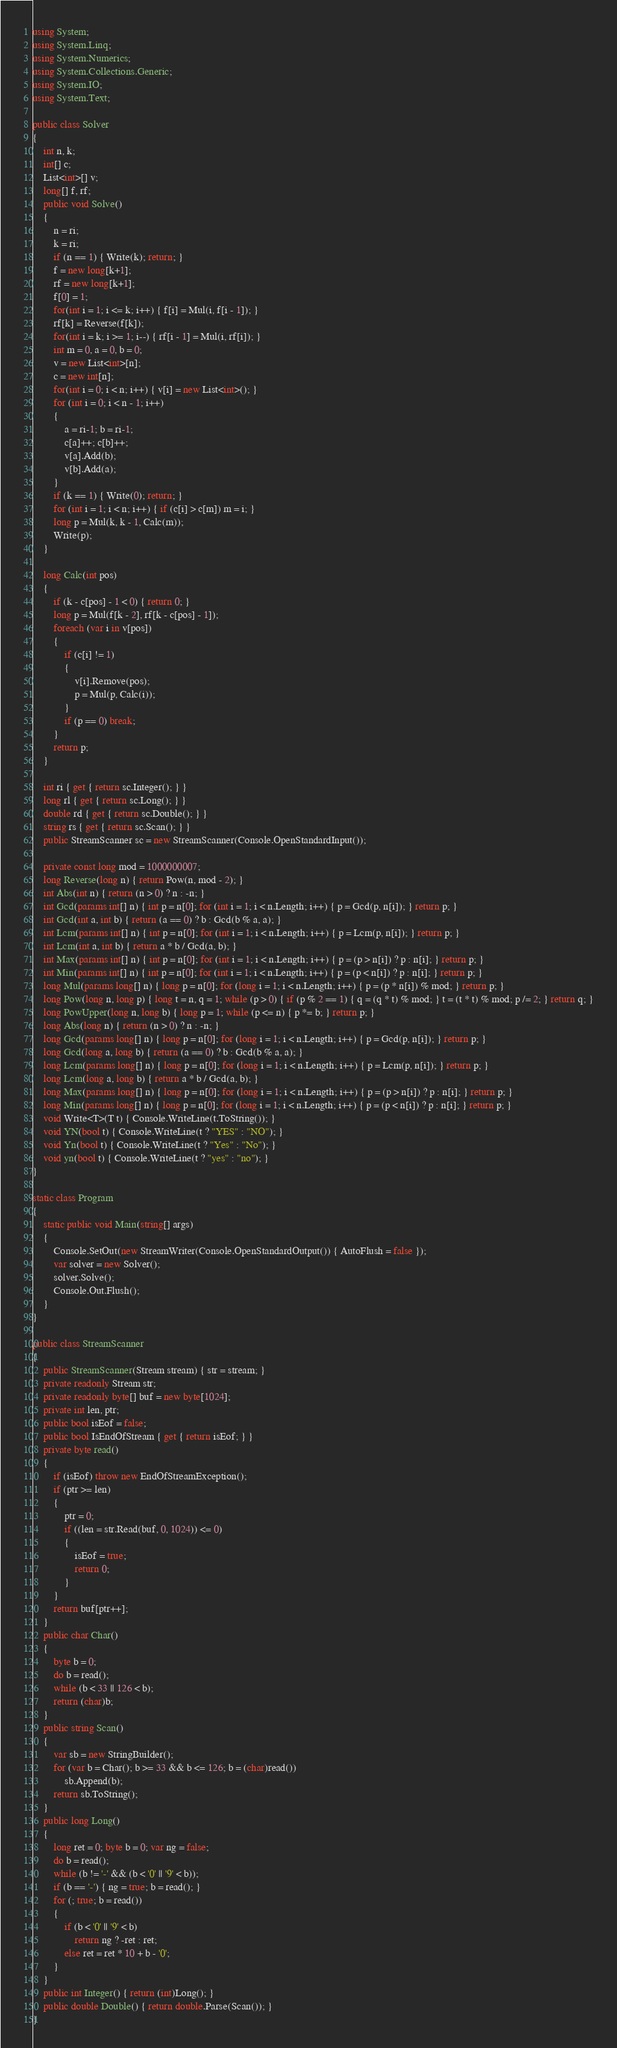Convert code to text. <code><loc_0><loc_0><loc_500><loc_500><_C#_>using System;
using System.Linq;
using System.Numerics;
using System.Collections.Generic;
using System.IO;
using System.Text;

public class Solver
{
    int n, k;
    int[] c;
    List<int>[] v;
    long[] f, rf;
    public void Solve()
    {
        n = ri;
        k = ri;
        if (n == 1) { Write(k); return; }
        f = new long[k+1];
        rf = new long[k+1];
        f[0] = 1;
        for(int i = 1; i <= k; i++) { f[i] = Mul(i, f[i - 1]); }
        rf[k] = Reverse(f[k]);
        for(int i = k; i >= 1; i--) { rf[i - 1] = Mul(i, rf[i]); }
        int m = 0, a = 0, b = 0;
        v = new List<int>[n];
        c = new int[n];
        for(int i = 0; i < n; i++) { v[i] = new List<int>(); }
        for (int i = 0; i < n - 1; i++)
        {
            a = ri-1; b = ri-1;
            c[a]++; c[b]++;
            v[a].Add(b);
            v[b].Add(a);
        }
        if (k == 1) { Write(0); return; }
        for (int i = 1; i < n; i++) { if (c[i] > c[m]) m = i; }
        long p = Mul(k, k - 1, Calc(m));
        Write(p);
    }

    long Calc(int pos)
    {
        if (k - c[pos] - 1 < 0) { return 0; }
        long p = Mul(f[k - 2], rf[k - c[pos] - 1]);
        foreach (var i in v[pos])
        {
            if (c[i] != 1)
            {
                v[i].Remove(pos);
                p = Mul(p, Calc(i));
            }
            if (p == 0) break;
        }
        return p;
    }

    int ri { get { return sc.Integer(); } }
    long rl { get { return sc.Long(); } }
    double rd { get { return sc.Double(); } }
    string rs { get { return sc.Scan(); } }
    public StreamScanner sc = new StreamScanner(Console.OpenStandardInput());
    
    private const long mod = 1000000007;
    long Reverse(long n) { return Pow(n, mod - 2); }
    int Abs(int n) { return (n > 0) ? n : -n; }
    int Gcd(params int[] n) { int p = n[0]; for (int i = 1; i < n.Length; i++) { p = Gcd(p, n[i]); } return p; }
    int Gcd(int a, int b) { return (a == 0) ? b : Gcd(b % a, a); }
    int Lcm(params int[] n) { int p = n[0]; for (int i = 1; i < n.Length; i++) { p = Lcm(p, n[i]); } return p; }
    int Lcm(int a, int b) { return a * b / Gcd(a, b); }
    int Max(params int[] n) { int p = n[0]; for (int i = 1; i < n.Length; i++) { p = (p > n[i]) ? p : n[i]; } return p; }
    int Min(params int[] n) { int p = n[0]; for (int i = 1; i < n.Length; i++) { p = (p < n[i]) ? p : n[i]; } return p; }
    long Mul(params long[] n) { long p = n[0]; for (long i = 1; i < n.Length; i++) { p = (p * n[i]) % mod; } return p; }
    long Pow(long n, long p) { long t = n, q = 1; while (p > 0) { if (p % 2 == 1) { q = (q * t) % mod; } t = (t * t) % mod; p /= 2; } return q; }
    long PowUpper(long n, long b) { long p = 1; while (p <= n) { p *= b; } return p; }
    long Abs(long n) { return (n > 0) ? n : -n; }
    long Gcd(params long[] n) { long p = n[0]; for (long i = 1; i < n.Length; i++) { p = Gcd(p, n[i]); } return p; }
    long Gcd(long a, long b) { return (a == 0) ? b : Gcd(b % a, a); }
    long Lcm(params long[] n) { long p = n[0]; for (long i = 1; i < n.Length; i++) { p = Lcm(p, n[i]); } return p; }
    long Lcm(long a, long b) { return a * b / Gcd(a, b); }
    long Max(params long[] n) { long p = n[0]; for (long i = 1; i < n.Length; i++) { p = (p > n[i]) ? p : n[i]; } return p; }
    long Min(params long[] n) { long p = n[0]; for (long i = 1; i < n.Length; i++) { p = (p < n[i]) ? p : n[i]; } return p; }
    void Write<T>(T t) { Console.WriteLine(t.ToString()); }
    void YN(bool t) { Console.WriteLine(t ? "YES" : "NO"); }
    void Yn(bool t) { Console.WriteLine(t ? "Yes" : "No"); }
    void yn(bool t) { Console.WriteLine(t ? "yes" : "no"); }
}

static class Program
{
    static public void Main(string[] args)
    {
        Console.SetOut(new StreamWriter(Console.OpenStandardOutput()) { AutoFlush = false });
        var solver = new Solver();
        solver.Solve();
        Console.Out.Flush();
    }
}

public class StreamScanner
{
    public StreamScanner(Stream stream) { str = stream; }
    private readonly Stream str;
    private readonly byte[] buf = new byte[1024];
    private int len, ptr;
    public bool isEof = false;
    public bool IsEndOfStream { get { return isEof; } }
    private byte read()
    {
        if (isEof) throw new EndOfStreamException();
        if (ptr >= len)
        {
            ptr = 0;
            if ((len = str.Read(buf, 0, 1024)) <= 0)
            {
                isEof = true;
                return 0;
            }
        }
        return buf[ptr++];
    }
    public char Char()
    {
        byte b = 0;
        do b = read();
        while (b < 33 || 126 < b);
        return (char)b;
    }
    public string Scan()
    {
        var sb = new StringBuilder();
        for (var b = Char(); b >= 33 && b <= 126; b = (char)read())
            sb.Append(b);
        return sb.ToString();
    }
    public long Long()
    {
        long ret = 0; byte b = 0; var ng = false;
        do b = read();
        while (b != '-' && (b < '0' || '9' < b));
        if (b == '-') { ng = true; b = read(); }
        for (; true; b = read())
        {
            if (b < '0' || '9' < b)
                return ng ? -ret : ret;
            else ret = ret * 10 + b - '0';
        }
    }
    public int Integer() { return (int)Long(); }
    public double Double() { return double.Parse(Scan()); }
}
</code> 